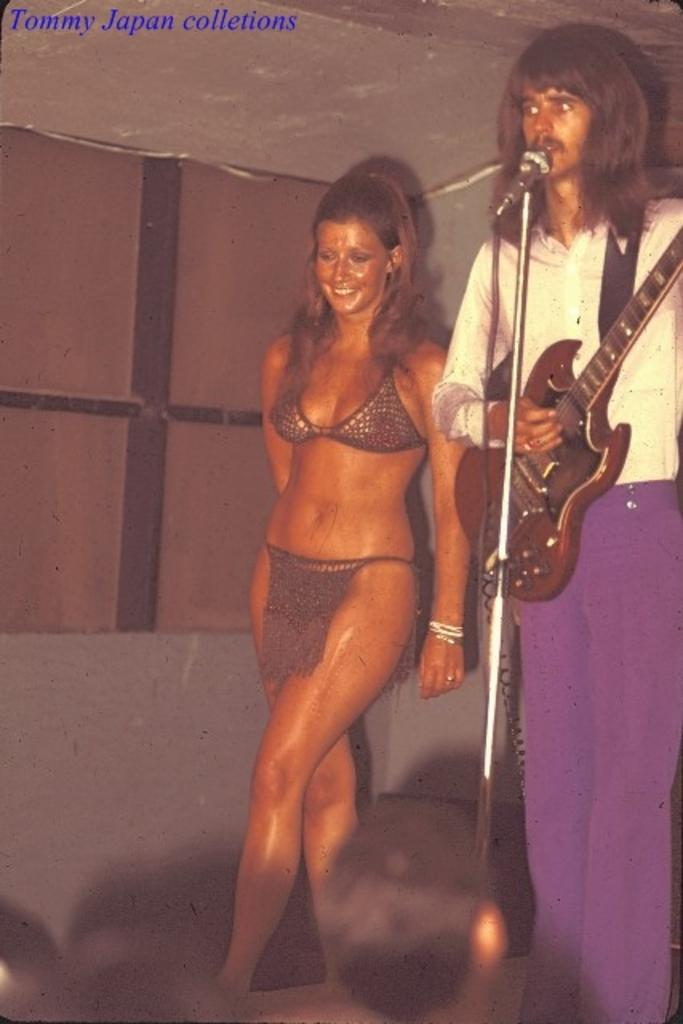How many people are in the image? There are two people in the image, a woman and a man. What are the positions of the woman and the man in the image? The woman is standing, and the man is standing as well. What is the woman's facial expression in the image? The woman is smiling in the image. What is the man holding in the image? The man is holding a guitar in the image. What object is in front of the man in the image? There is a microphone in front of the man in the image. What type of maid can be seen cleaning the edge of the class in the image? There is no maid, edge, or class present in the image. 